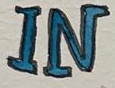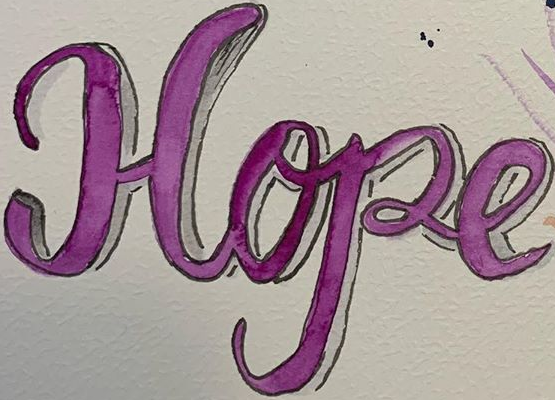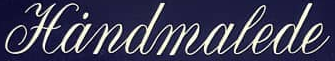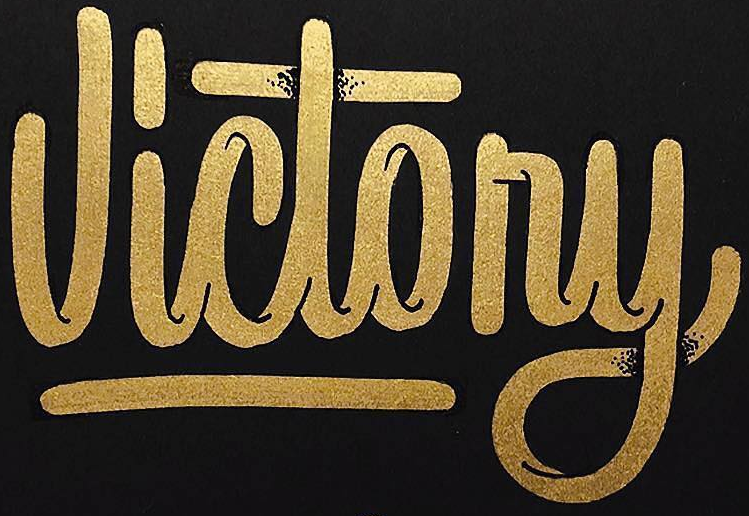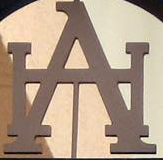Identify the words shown in these images in order, separated by a semicolon. IN; Hope; Hȧndmalede; Victony; HA 